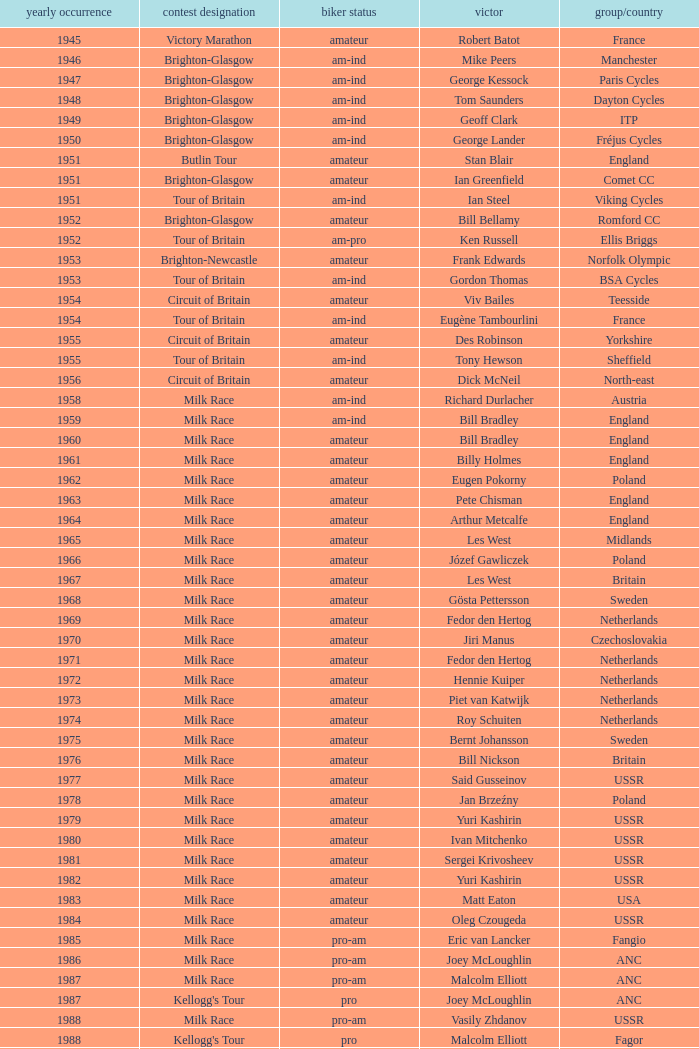Who was the winner in 1973 with an amateur rider status? Piet van Katwijk. 